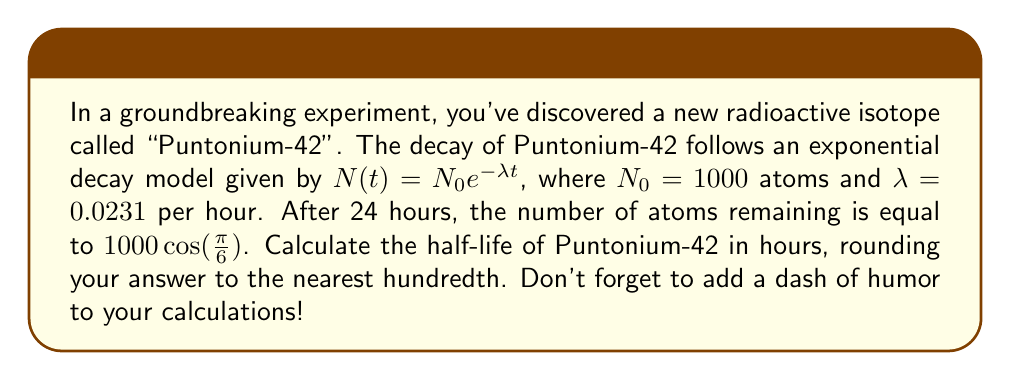What is the answer to this math problem? Let's break this down step by step:

1) We're given the exponential decay model: $N(t) = N_0 e^{-\lambda t}$
   Where $N_0 = 1000$ atoms and $\lambda = 0.0231$ per hour

2) After 24 hours, the number of atoms is equal to $1000 \cos(\frac{\pi}{6})$
   So, we can write: $N(24) = 1000 \cos(\frac{\pi}{6})$

3) Let's calculate $\cos(\frac{\pi}{6})$:
   $\cos(\frac{\pi}{6}) = \frac{\sqrt{3}}{2} \approx 0.866$

4) Now, we can set up our equation:
   $1000 e^{-0.0231 * 24} = 1000 * 0.866$

5) Simplify:
   $e^{-0.0231 * 24} = 0.866$

6) Take natural log of both sides:
   $-0.0231 * 24 = \ln(0.866)$

7) Solve for $\lambda$:
   $\lambda = \frac{-\ln(0.866)}{24} \approx 0.00598$

8) Now that we have $\lambda$, we can use the half-life formula:
   $t_{1/2} = \frac{\ln(2)}{\lambda}$

9) Plug in our value for $\lambda$:
   $t_{1/2} = \frac{\ln(2)}{0.00598} \approx 115.92$ hours

10) Rounding to the nearest hundredth:
    $t_{1/2} \approx 115.92$ hours

And there you have it! The half-life of Puntonium-42 is approximately 115.92 hours. That's a pretty long time for a pun to decay, but I guess some jokes just have staying power!
Answer: 115.92 hours 